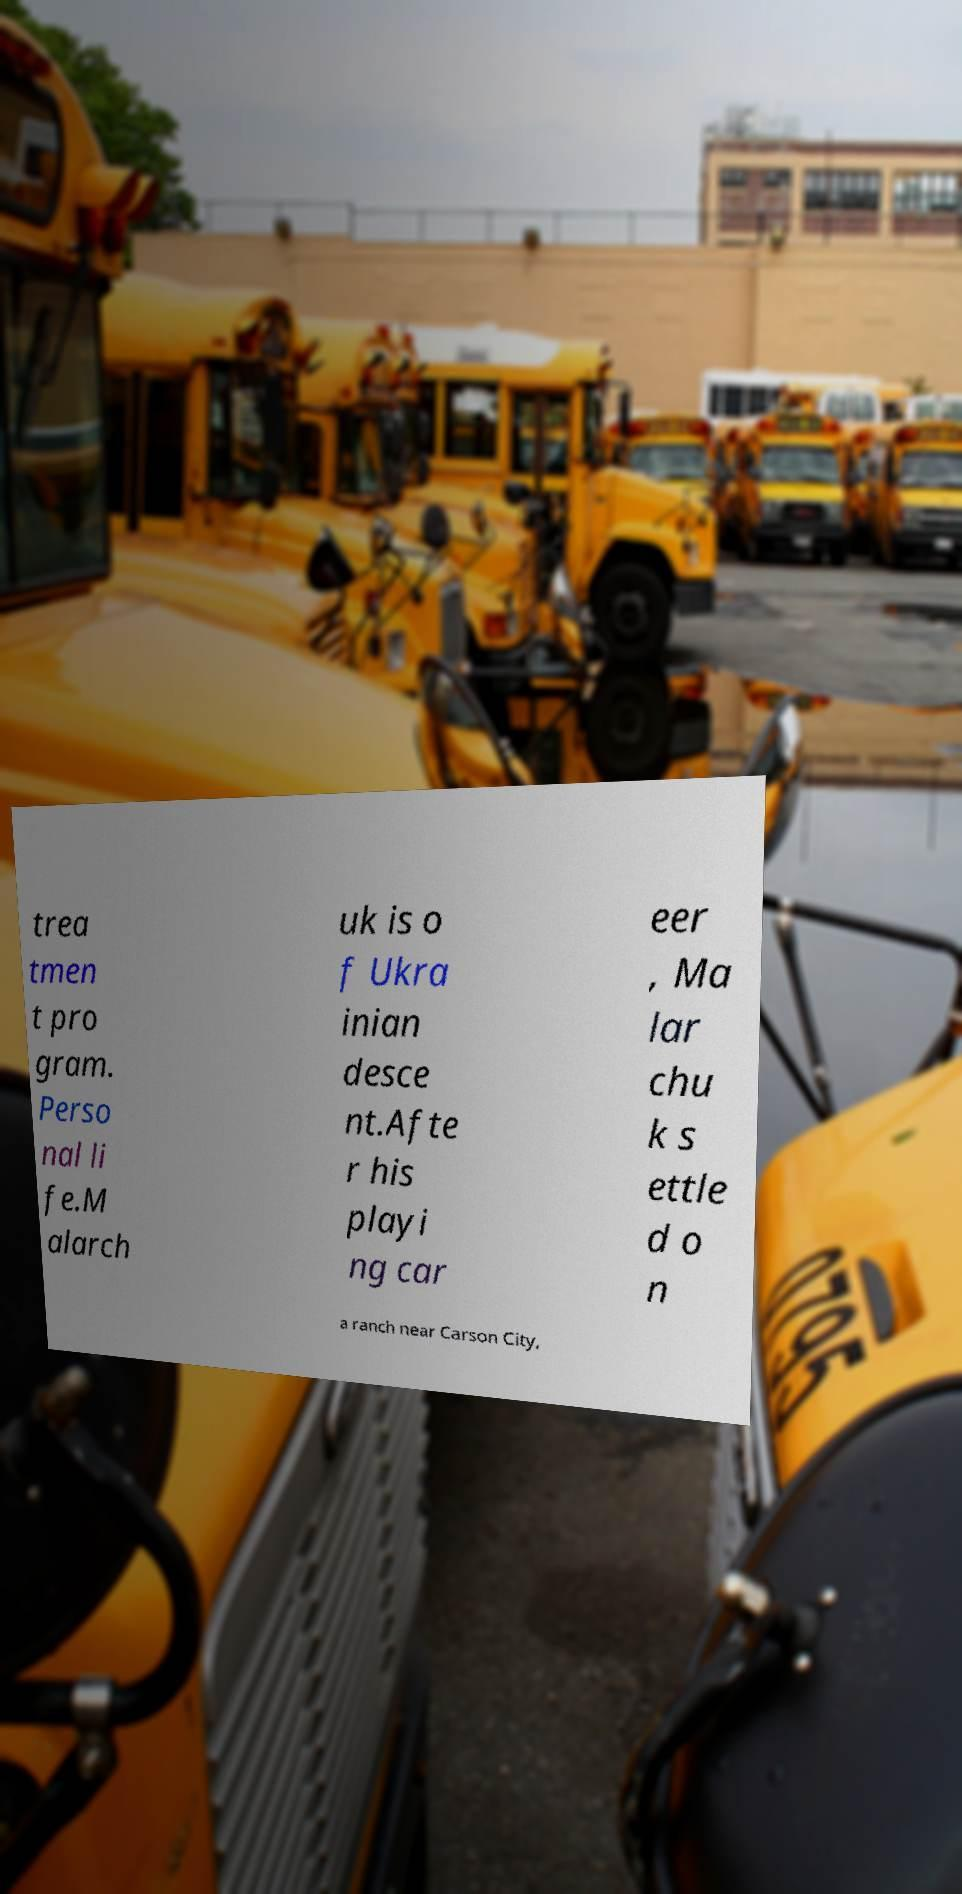Could you extract and type out the text from this image? trea tmen t pro gram. Perso nal li fe.M alarch uk is o f Ukra inian desce nt.Afte r his playi ng car eer , Ma lar chu k s ettle d o n a ranch near Carson City, 